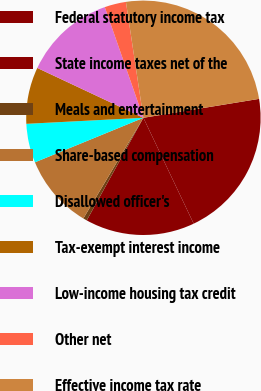Convert chart. <chart><loc_0><loc_0><loc_500><loc_500><pie_chart><fcel>Federal statutory income tax<fcel>State income taxes net of the<fcel>Meals and entertainment<fcel>Share-based compensation<fcel>Disallowed officer's<fcel>Tax-exempt interest income<fcel>Low-income housing tax credit<fcel>Other net<fcel>Effective income tax rate<nl><fcel>20.52%<fcel>15.09%<fcel>0.53%<fcel>10.24%<fcel>5.38%<fcel>7.81%<fcel>12.67%<fcel>2.96%<fcel>24.8%<nl></chart> 